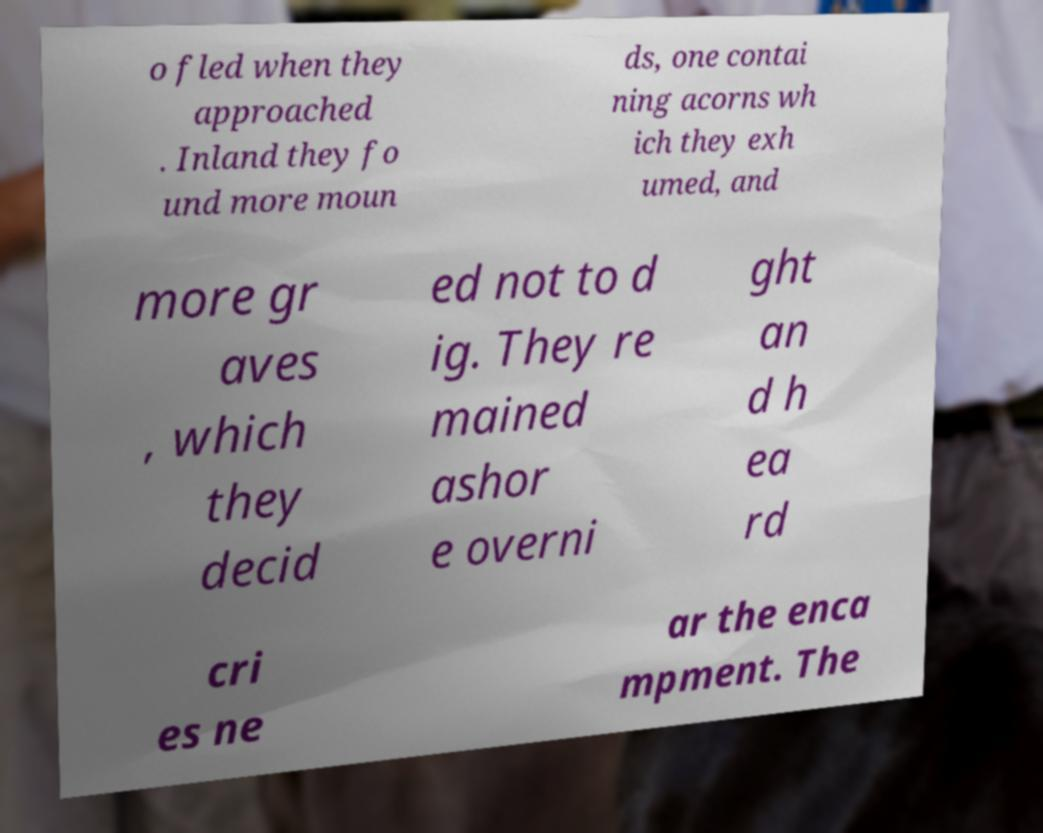Could you assist in decoding the text presented in this image and type it out clearly? o fled when they approached . Inland they fo und more moun ds, one contai ning acorns wh ich they exh umed, and more gr aves , which they decid ed not to d ig. They re mained ashor e overni ght an d h ea rd cri es ne ar the enca mpment. The 